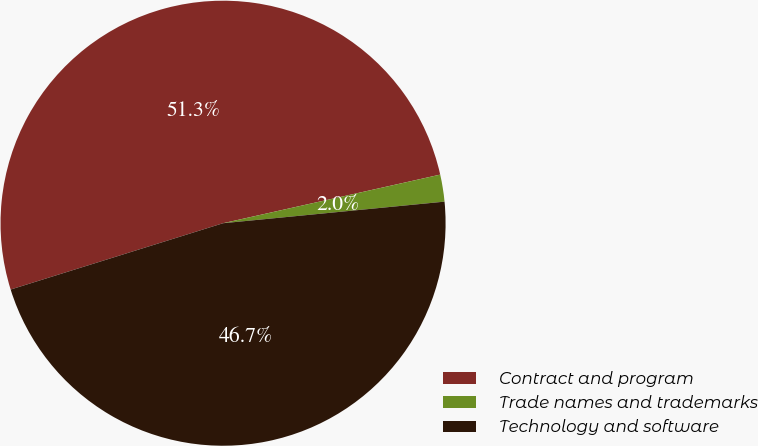Convert chart to OTSL. <chart><loc_0><loc_0><loc_500><loc_500><pie_chart><fcel>Contract and program<fcel>Trade names and trademarks<fcel>Technology and software<nl><fcel>51.31%<fcel>1.96%<fcel>46.73%<nl></chart> 